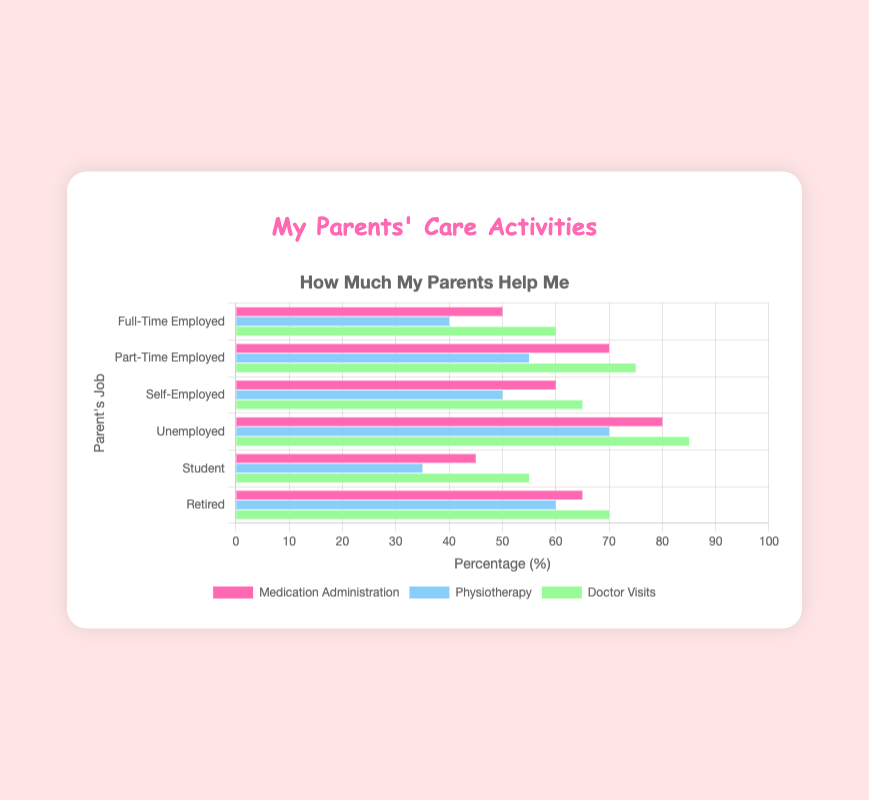Which employment status shows the highest percentage of parental involvement in Doctor Visits? Look at the Doctor Visits bars across different employment statuses and find the longest (green) bar. The Unemployed category has the longest bar for Doctor Visits.
Answer: Unemployed Which employment status is involved more in Physiotherapy, Self-Employed or Retired? Compare the lengths of the Physiotherapy (blue) bars for Self-Employed and Retired. The Retired category has a longer blue bar.
Answer: Retired How much more involvement is there in Medication Administration for the Unemployed compared to Students? Find the Medication Administration (pink) bars for Unemployed and Students, then subtract the value for Students (45) from Unemployed (80).
Answer: 35 What is the total parental involvement in all activities for Part-Time Employed? Sum the values for Medication Administration, Physiotherapy, and Doctor Visits for Part-Time Employed (70 + 55 + 75).
Answer: 200 Does Full-Time or Part-Time Employed show higher involvement in Physiotherapy? Compare the Physiotherapy (blue) bars for Full-Time and Part-Time Employed. The Part-Time Employed category has a higher value.
Answer: Part-Time Employed Rank the employment statuses from highest to lowest involvement in Medication Administration. Compare the lengths of the Medication Administration (pink) bars for all employment statuses and rank them: Unemployed (80), Part-Time Employed (70), Retired (65), Self-Employed (60), Full-Time Employed (50), Student (45).
Answer: Unemployed, Part-Time Employed, Retired, Self-Employed, Full-Time Employed, Student Which employment status has the least involvement in Doctor Visits? Find the Doctor Visits (green) bars and identify the shortest one, which belongs to the Student category.
Answer: Student Is there a noticeable difference in Physiotherapy involvement between Full-Time Employed and Unemployed parents? Compare the Physiotherapy (blue) bars for Full-Time Employed (40) and Unemployed (70). The Unemployed involvement is noticeably higher than Full-Time Employed.
Answer: Yes Calculate the average involvement in Doctor Visits across all employment statuses. Average the Doctor Visits values: (60 + 75 + 65 + 85 + 55 + 70) / 6. The sum is 410, divide it by 6 to get approximately 68.33.
Answer: 68.33 